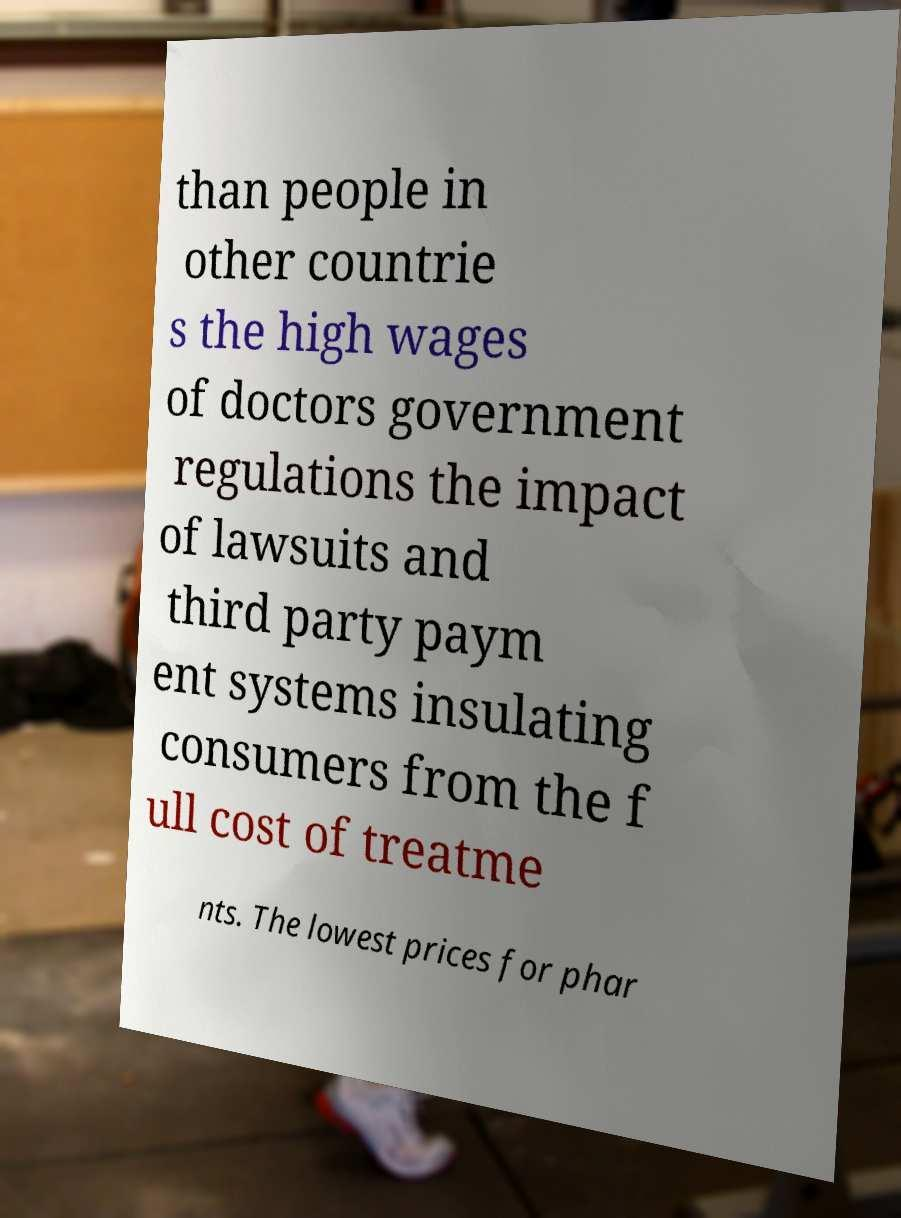Could you assist in decoding the text presented in this image and type it out clearly? than people in other countrie s the high wages of doctors government regulations the impact of lawsuits and third party paym ent systems insulating consumers from the f ull cost of treatme nts. The lowest prices for phar 